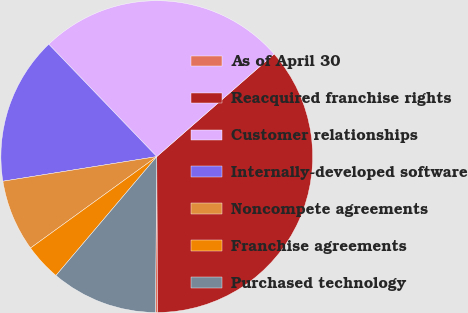Convert chart to OTSL. <chart><loc_0><loc_0><loc_500><loc_500><pie_chart><fcel>As of April 30<fcel>Reacquired franchise rights<fcel>Customer relationships<fcel>Internally-developed software<fcel>Noncompete agreements<fcel>Franchise agreements<fcel>Purchased technology<nl><fcel>0.22%<fcel>36.35%<fcel>25.75%<fcel>15.34%<fcel>7.45%<fcel>3.83%<fcel>11.06%<nl></chart> 